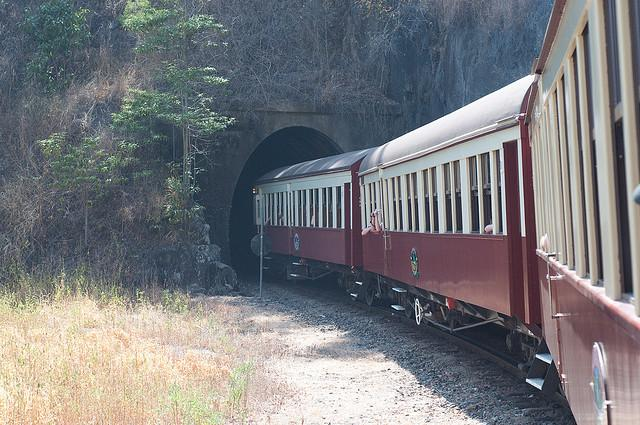If the train continues forward what will make it go out of sight first? tunnel 